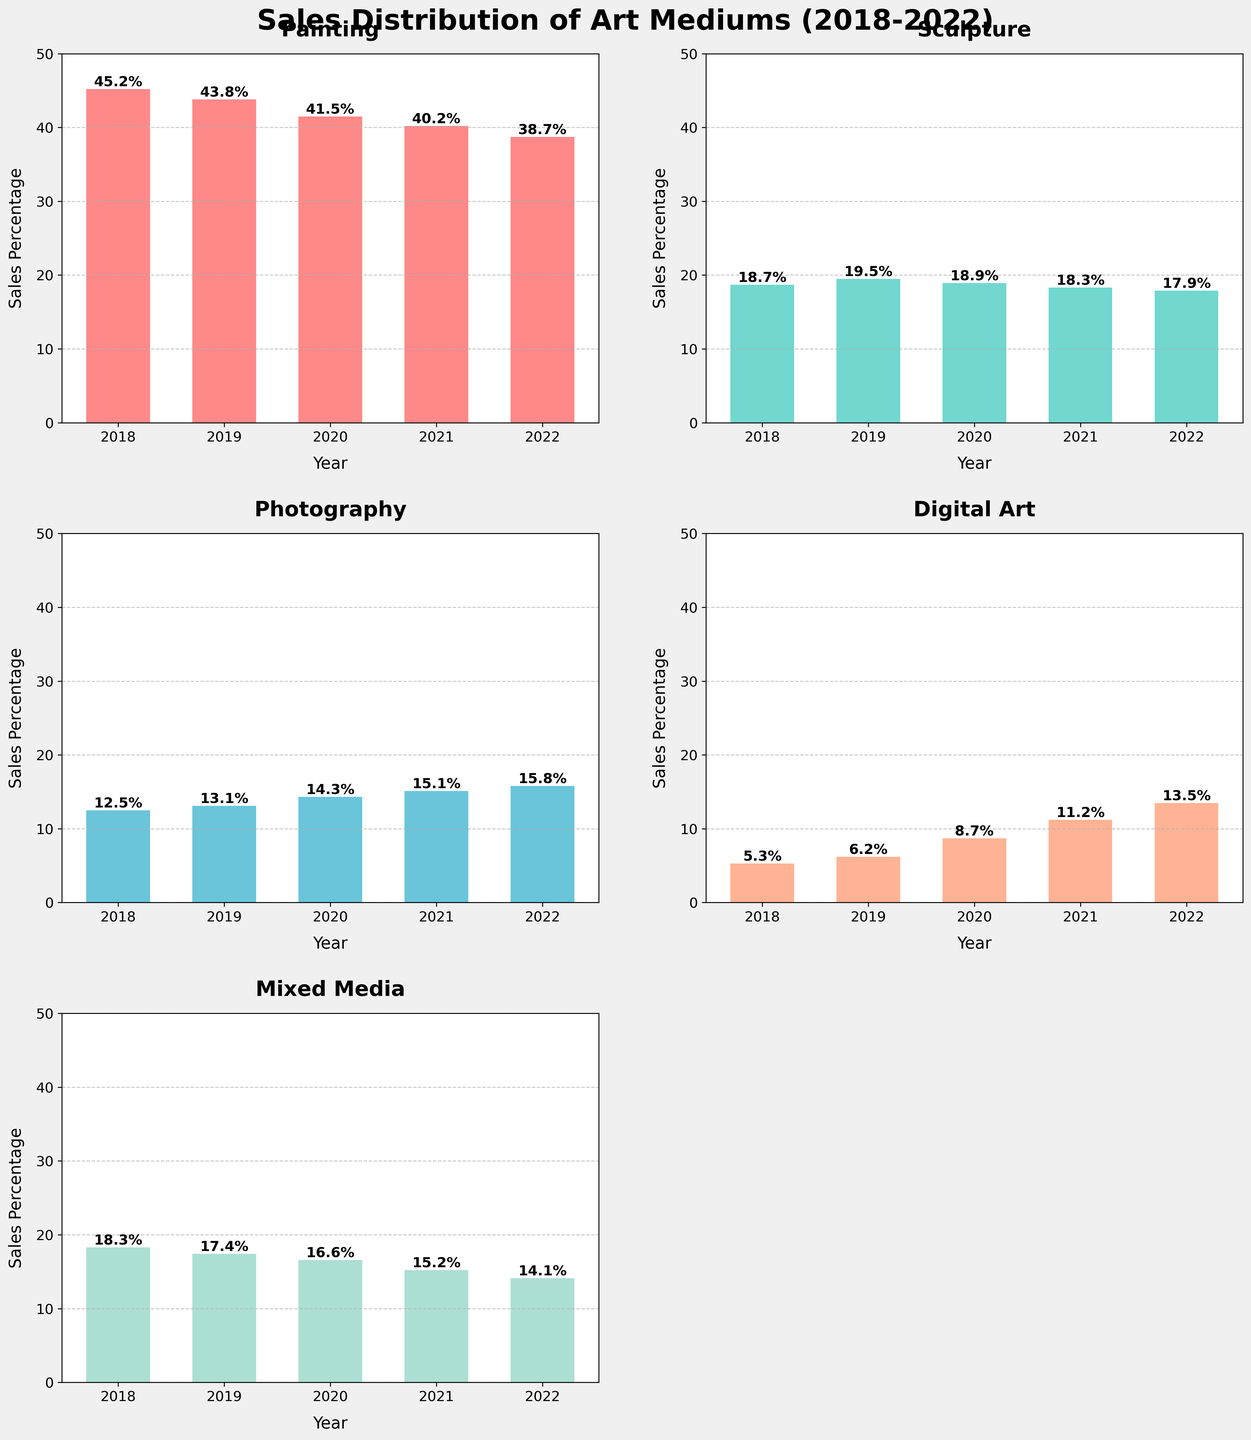Which medium saw the highest sales percentage in 2022? Referring to the 'Digital Art' subplot for the year 2022, it shows the highest percentage at 13.5%.
Answer: Digital Art How did the sales percentage of Painting change from 2018 to 2022? The bar for 'Painting' shows a decrease from 45.2% in 2018 to 38.7% in 2022.
Answer: Decrease Which medium had the most stable sales percentage over the years? The 'Sculpture' subplot shows minimal variation from 18.7% in 2018 to 17.9% in 2022, highlighting it as the most stable.
Answer: Sculpture What’s the total sales percentage of Photography from 2018 to 2022? Adding up the percentages shown in the 'Photography' subplot: 12.5 + 13.1 + 14.3 + 15.1 + 15.8 = 70.8%.
Answer: 70.8% Which medium showed the highest increase in sales percentage from 2018 to 2022? 'Digital Art' subplot shows the most significant increase from 5.3% in 2018 to 13.5% in 2022, an increase of 8.2 percentage points.
Answer: Digital Art Between 2018 and 2020, which medium recorded a drop in its sales percentage, and by how much? 'Painting' subplot shows a drop from 45.2% to 41.5%, a decrease of 3.7 percentage points.
Answer: Painting, 3.7 How does the sales distribution in 2021 compare to that in 2022 for Mixed Media? The 'Mixed Media' subplot shows a sales percentage of 15.2% in 2021 and 14.1% in 2022, indicating a decrease.
Answer: Decrease In which year did Photography surpass 15% sales for the first time? The 'Photography' subplot indicates that sales first surpassed 15% in 2021.
Answer: 2021 What’s the average sales percentage of Sculpture over the five years shown? The 'Sculpture' subplot shows the percentages: 18.7, 19.5, 18.9, 18.3, and 17.9. The average is (18.7 + 19.5 + 18.9 + 18.3 + 17.9) / 5 = 18.66%.
Answer: 18.66% Which medium had the lowest sales percentage in 2019 and what was it? The 'Digital Art' subplot shows that it had the lowest percentage in 2019 at 6.2%.
Answer: Digital Art, 6.2% 